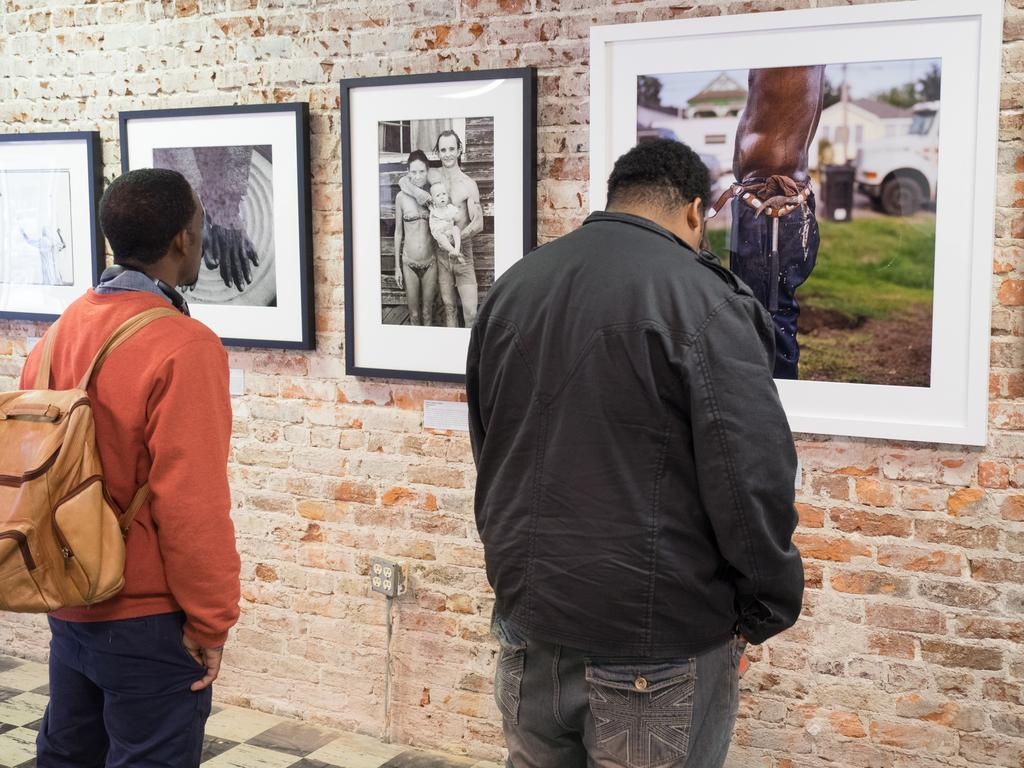How many people are present in the image? There are two people standing in the image. Can you describe the attire of one of the people? One of the people is wearing a bag. What can be seen on the brick wall in front of the two people? There are photo frames of people on the brick wall. What type of chin is visible on the person wearing the bag in the image? There is no chin visible on the person wearing the bag in the image, as the image does not show the person's face. 